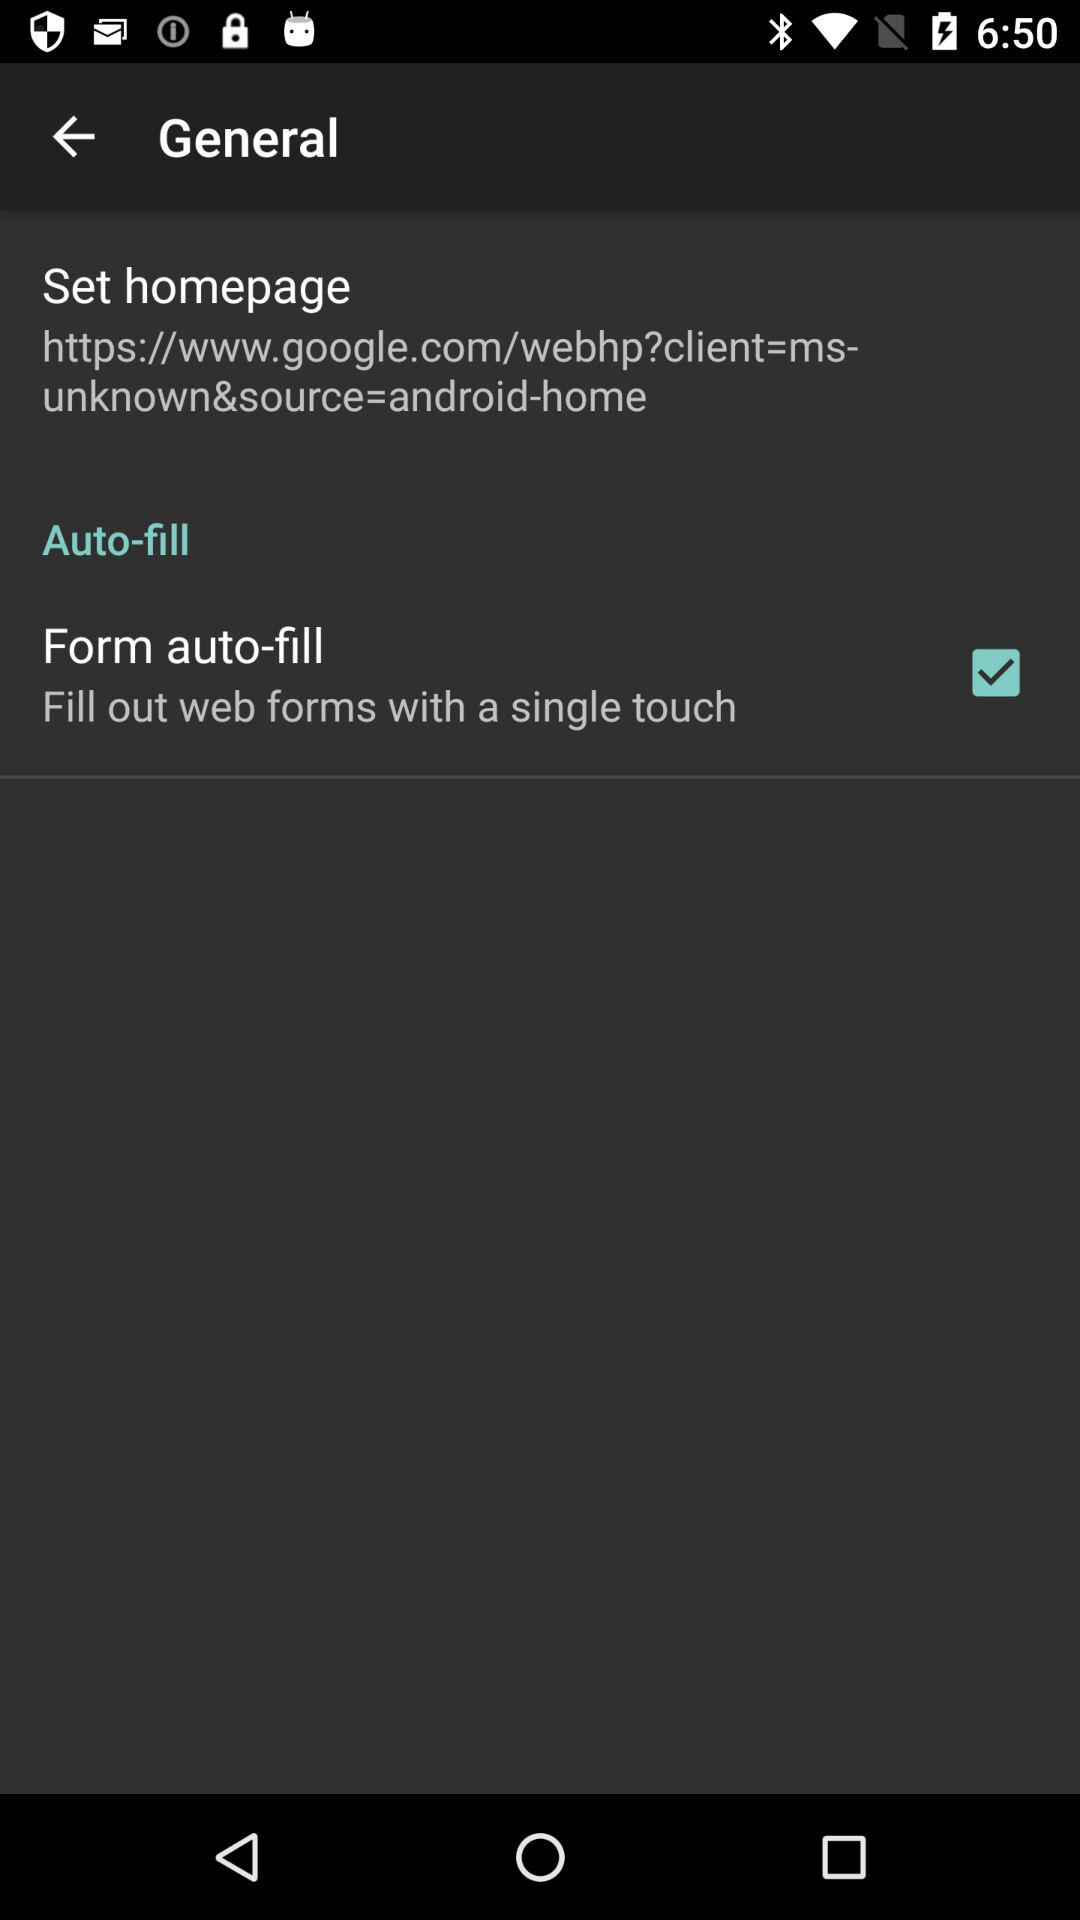What is the status of "Form auto-fill"? The status of "Form auto-fill" is "on". 